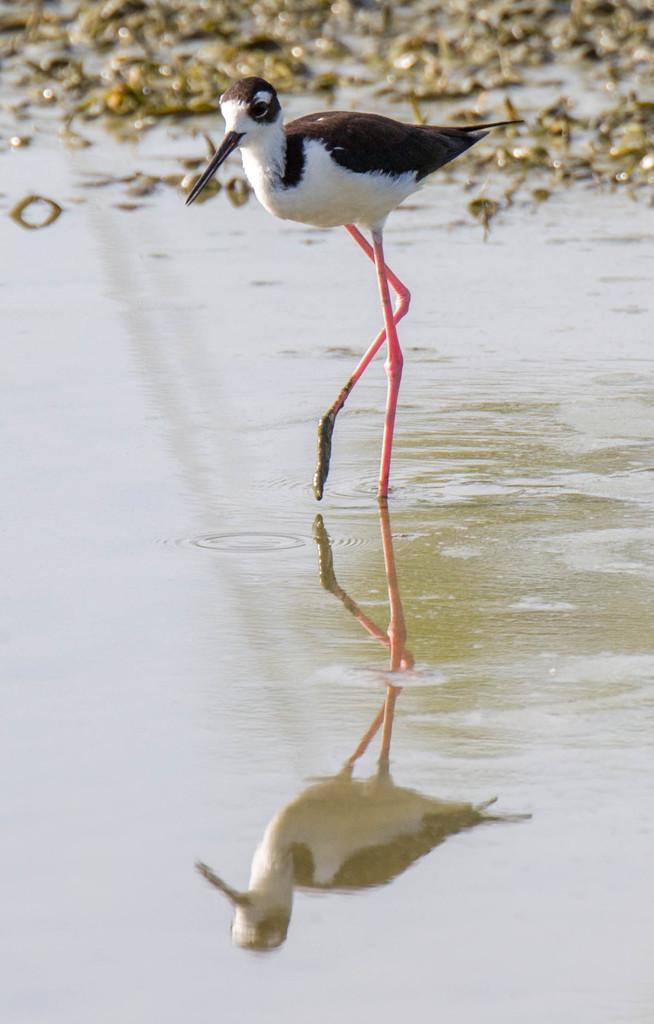How would you summarize this image in a sentence or two? In this picture, we see a bird in brown and white color. It has a long beak. It also has long legs. At the bottom, we see water and this water might be in the pond. In the background, it might be the grass or insects. This picture is blurred in the background. 